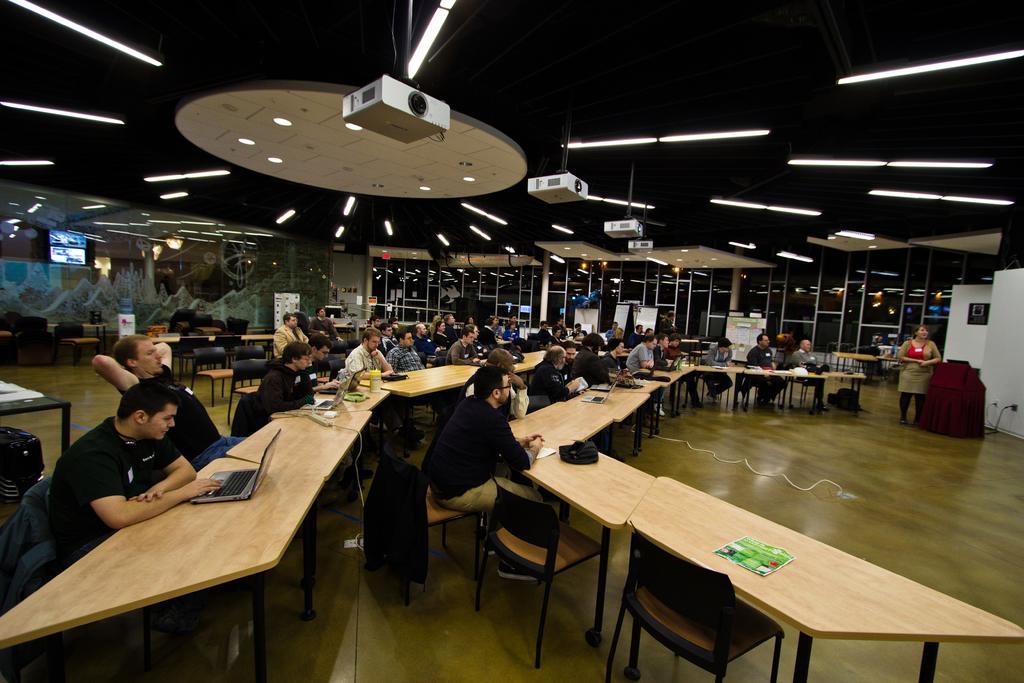How would you summarize this image in a sentence or two? This is a picture of a room. In the room there are tables, chairs and many people seated. On the right there is a podium, beside the podium a woman is standing. In the background there are windows. On the top left the television. On the top to the ceiling there are lights and projectors. On the table there are laptops and papers. 